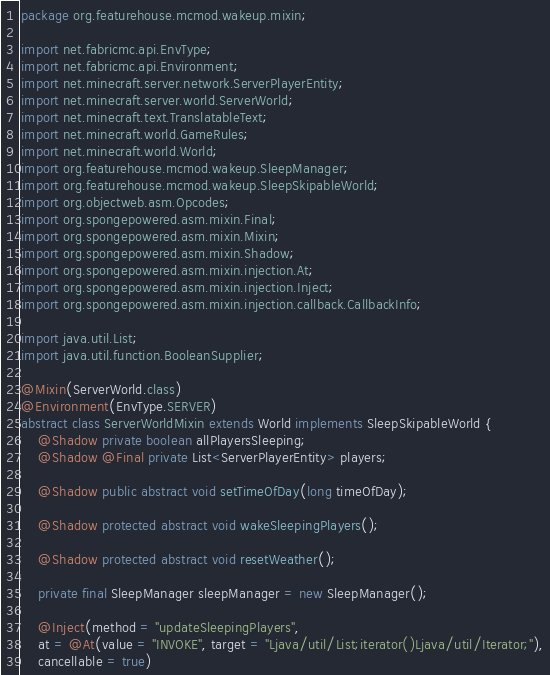Convert code to text. <code><loc_0><loc_0><loc_500><loc_500><_Java_>package org.featurehouse.mcmod.wakeup.mixin;

import net.fabricmc.api.EnvType;
import net.fabricmc.api.Environment;
import net.minecraft.server.network.ServerPlayerEntity;
import net.minecraft.server.world.ServerWorld;
import net.minecraft.text.TranslatableText;
import net.minecraft.world.GameRules;
import net.minecraft.world.World;
import org.featurehouse.mcmod.wakeup.SleepManager;
import org.featurehouse.mcmod.wakeup.SleepSkipableWorld;
import org.objectweb.asm.Opcodes;
import org.spongepowered.asm.mixin.Final;
import org.spongepowered.asm.mixin.Mixin;
import org.spongepowered.asm.mixin.Shadow;
import org.spongepowered.asm.mixin.injection.At;
import org.spongepowered.asm.mixin.injection.Inject;
import org.spongepowered.asm.mixin.injection.callback.CallbackInfo;

import java.util.List;
import java.util.function.BooleanSupplier;

@Mixin(ServerWorld.class)
@Environment(EnvType.SERVER)
abstract class ServerWorldMixin extends World implements SleepSkipableWorld {
    @Shadow private boolean allPlayersSleeping;
    @Shadow @Final private List<ServerPlayerEntity> players;

    @Shadow public abstract void setTimeOfDay(long timeOfDay);

    @Shadow protected abstract void wakeSleepingPlayers();

    @Shadow protected abstract void resetWeather();

    private final SleepManager sleepManager = new SleepManager();

    @Inject(method = "updateSleepingPlayers",
    at = @At(value = "INVOKE", target = "Ljava/util/List;iterator()Ljava/util/Iterator;"),
    cancellable = true)</code> 